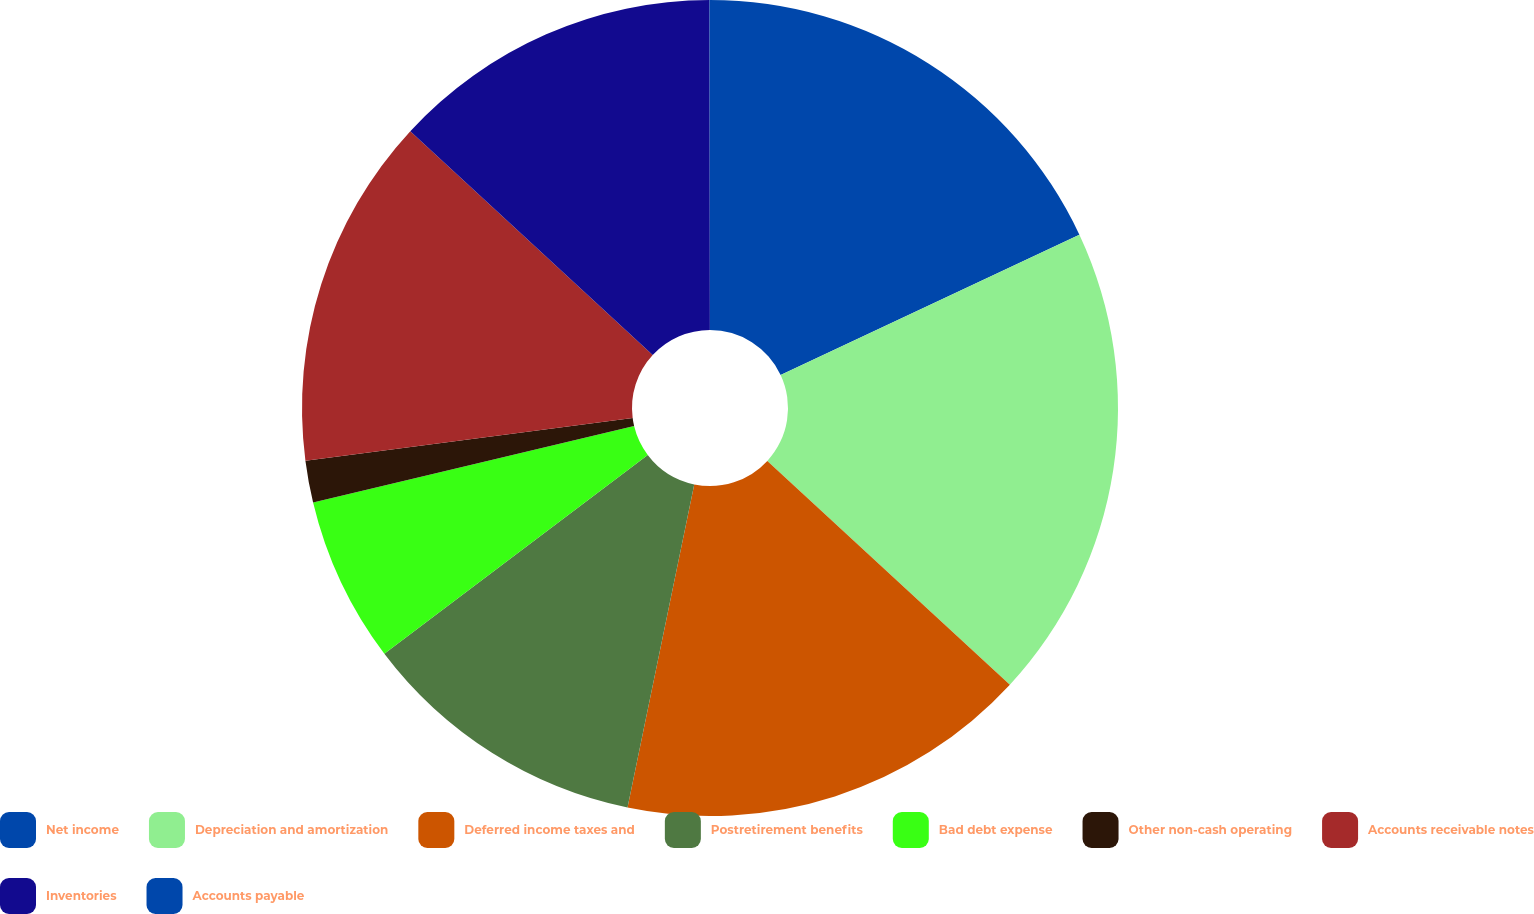Convert chart. <chart><loc_0><loc_0><loc_500><loc_500><pie_chart><fcel>Net income<fcel>Depreciation and amortization<fcel>Deferred income taxes and<fcel>Postretirement benefits<fcel>Bad debt expense<fcel>Other non-cash operating<fcel>Accounts receivable notes<fcel>Inventories<fcel>Accounts payable<nl><fcel>18.02%<fcel>18.84%<fcel>16.38%<fcel>11.47%<fcel>6.57%<fcel>1.66%<fcel>13.93%<fcel>13.11%<fcel>0.02%<nl></chart> 